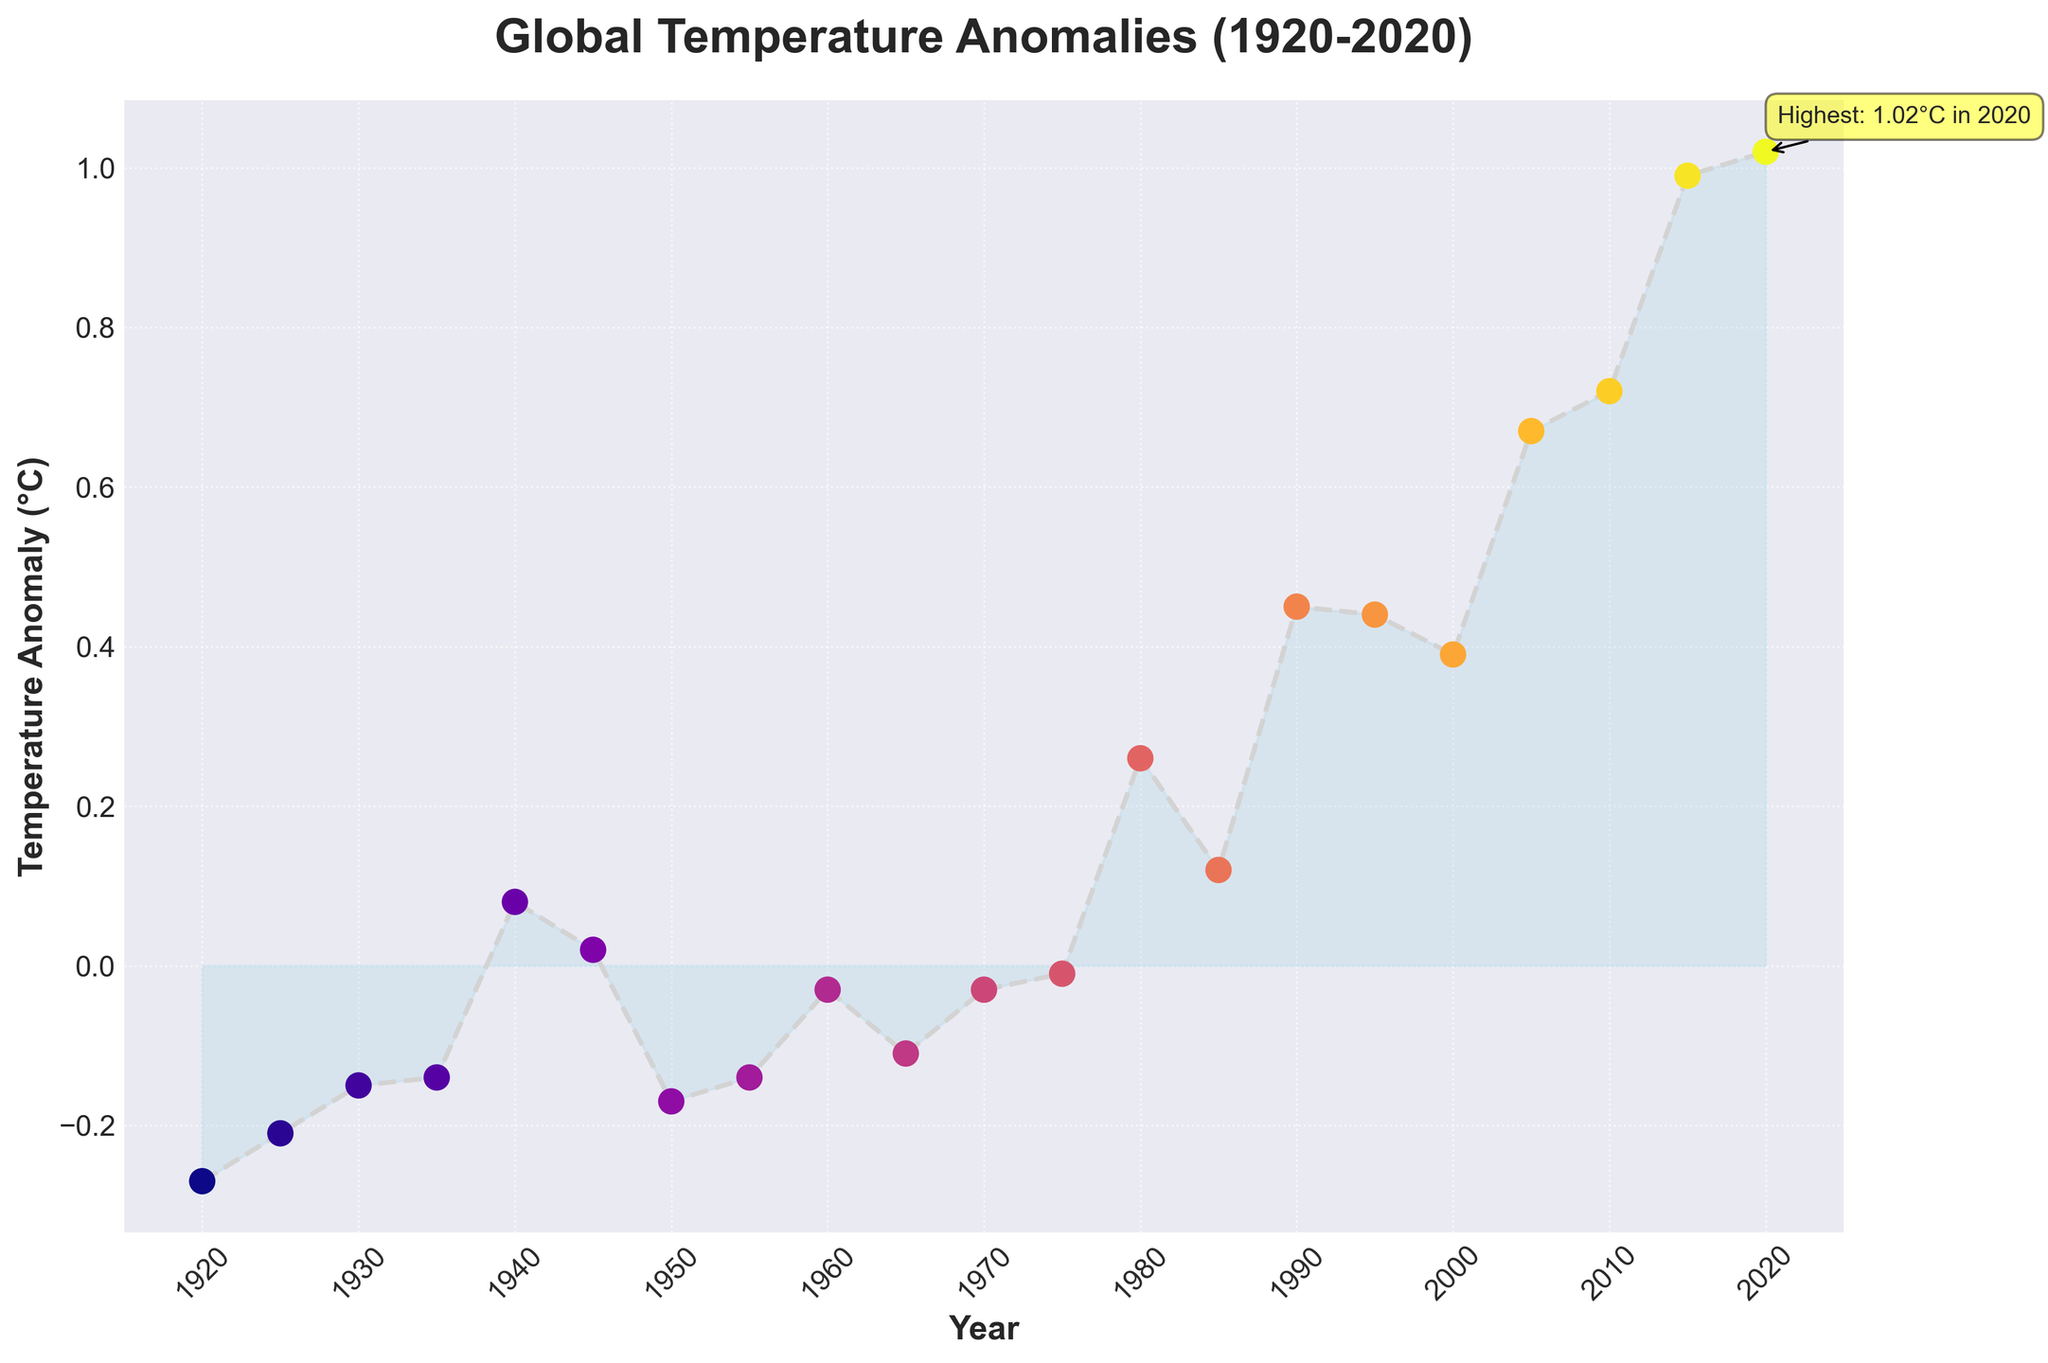What is the temperature anomaly in 1980? Locate the year '1980' on the x-axis and find the corresponding point on the y-axis, which represents the temperature anomaly. The figure shows the point near 0.26°C.
Answer: 0.26°C How much did the temperature anomaly increase from 1940 to 2020? Find the temperature anomalies for years 1940 and 2020 from the figure. The anomaly in 1940 is approximately 0.08°C and in 2020 it is 1.02°C. Subtract the 1940 value from the 2020 value: 1.02°C - 0.08°C = 0.94°C.
Answer: 0.94°C During which period(s) did the temperature anomaly decrease? Observe the trend of the line for periods where it slopes downward. The figure shows decreases from 1940 to 1950 and other minor fluctuations that generally reverse in shorter spans.
Answer: 1940 to 1950 What is the highest temperature anomaly recorded and in which year did it occur? The figure marks the highest point with an annotation indicating that it is the temperature anomaly of 1.02°C in the year 2020.
Answer: 1.02°C in 2020 Compare the temperature anomalies in 1920 and 2020. How much has it changed? Find the temperature anomalies for both years in the figure. In 1920, the temperature anomaly is approximately -0.27°C, and in 2020, it is 1.02°C. Calculate the change: 1.02°C - (-0.27°C) = 1.29°C.
Answer: 1.29°C What is the general trend of the temperature anomalies over the century? Observe the overall direction of the plotted line from the start to the end of the timeline. It generally trends upwards, despite some fluctuations, indicating a rise in temperature anomalies over the century.
Answer: Upward trend By how much did the temperature anomaly increase from 1985 to 2005? Identify the temperature anomalies for 1985 and 2005 on the plot. In 1985, it is approximately 0.12°C, and in 2005, it is about 0.67°C. Subtract to find the increase: 0.67°C - 0.12°C = 0.55°C.
Answer: 0.55°C During which decade did the temperature anomaly first become positive? Look for the initial transition from negative to positive temperature anomalies. This occurs around the year 1980.
Answer: 1980s 